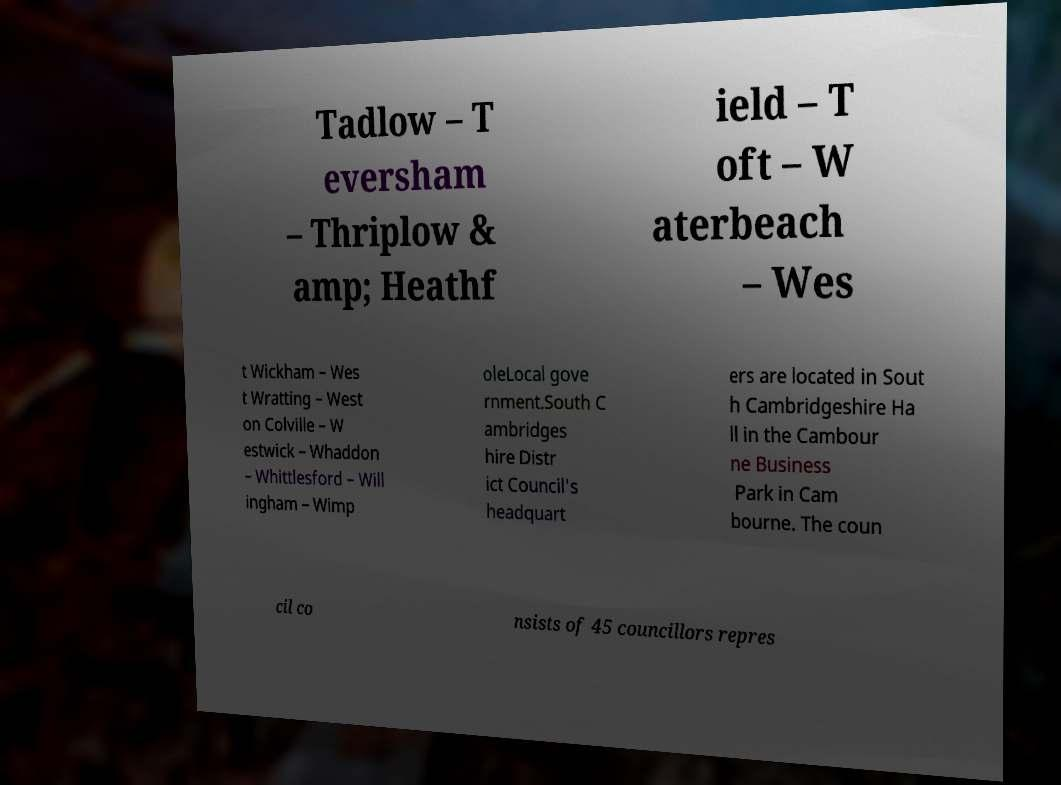There's text embedded in this image that I need extracted. Can you transcribe it verbatim? Tadlow – T eversham – Thriplow & amp; Heathf ield – T oft – W aterbeach – Wes t Wickham – Wes t Wratting – West on Colville – W estwick – Whaddon – Whittlesford – Will ingham – Wimp oleLocal gove rnment.South C ambridges hire Distr ict Council's headquart ers are located in Sout h Cambridgeshire Ha ll in the Cambour ne Business Park in Cam bourne. The coun cil co nsists of 45 councillors repres 